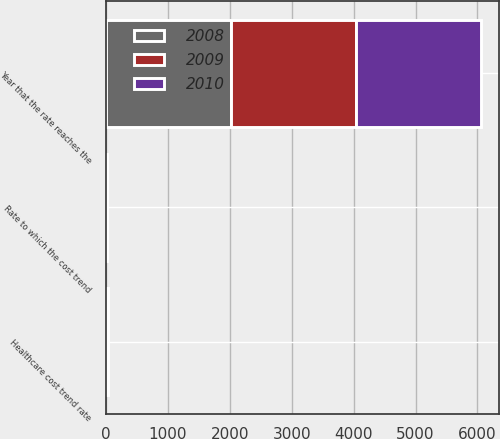<chart> <loc_0><loc_0><loc_500><loc_500><stacked_bar_chart><ecel><fcel>Healthcare cost trend rate<fcel>Rate to which the cost trend<fcel>Year that the rate reaches the<nl><fcel>2010<fcel>7.9<fcel>4.51<fcel>2018<nl><fcel>2008<fcel>8.38<fcel>4.51<fcel>2018<nl><fcel>2009<fcel>8.91<fcel>4.52<fcel>2017<nl></chart> 